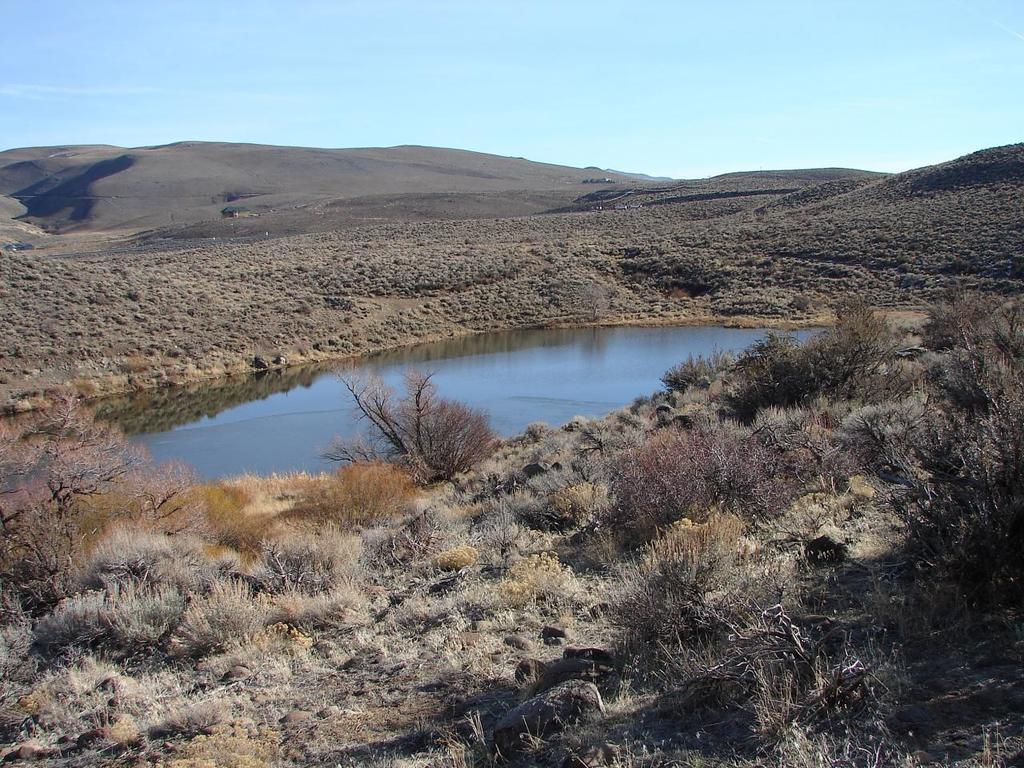What object is present in the image? There is a pot in the image. What type of vegetation can be seen in the image? There is grass visible in the image. What geographical feature is present in the image? There are sand hills in the image. How many women are riding bikes in the image? There are no women or bikes present in the image. 